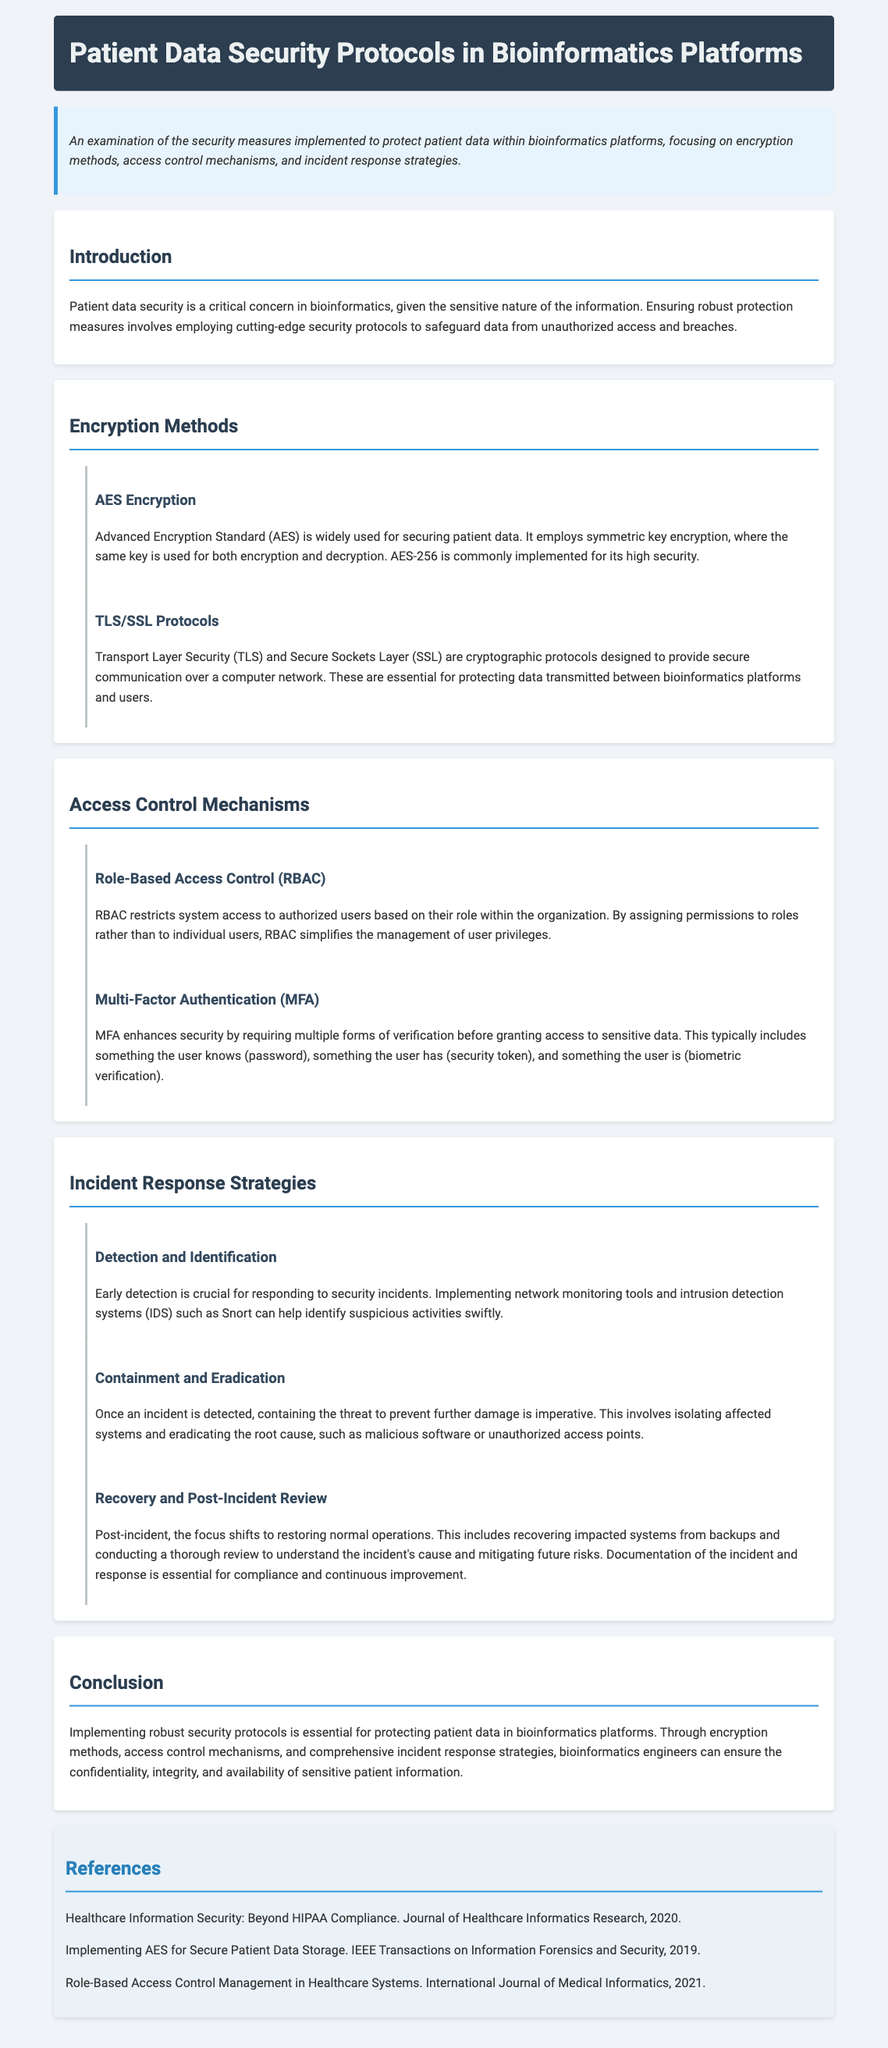what encryption method is commonly implemented for its high security? The document states that AES-256 is commonly implemented for its high security.
Answer: AES-256 which protocol is essential for protecting data transmitted between platforms? The document mentions that TLS and SSL are essential for protecting data transmitted.
Answer: TLS/SSL what access control mechanism simplifies management of user privileges? The document explains that RBAC simplifies the management of user privileges.
Answer: RBAC what is required by Multi-Factor Authentication? According to the document, MFA typically requires something the user knows, has, and is.
Answer: Multiple forms of verification which strategy involves isolating affected systems? The document describes containment and eradication as involving isolating affected systems.
Answer: Containment and eradication what is the purpose of early detection in incident response? The document emphasizes that early detection is crucial for responding to security incidents.
Answer: Responding to security incidents what is the focus during the recovery phase post-incident? The document highlights that the focus shifts to restoring normal operations during recovery.
Answer: Restoring normal operations which document section describes encryption methods? The section that discusses encryption methods is named "Encryption Methods."
Answer: Encryption Methods how many references are listed in the document? The document contains a section titled "References" which includes a list of references.
Answer: Three references 